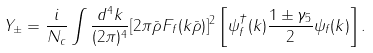Convert formula to latex. <formula><loc_0><loc_0><loc_500><loc_500>Y _ { \pm } = \frac { i } { N _ { c } } \int \frac { d ^ { 4 } k } { ( 2 \pi ) ^ { 4 } } [ 2 \pi \bar { \rho } F _ { f } ( k \bar { \rho } ) ] ^ { 2 } \left [ \psi _ { f } ^ { \dagger } ( k ) \frac { 1 \pm \gamma _ { 5 } } { 2 } \psi _ { f } ( k ) \right ] .</formula> 